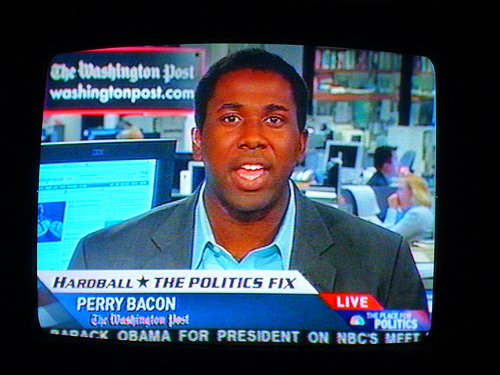<image>
Is there a announcer behind the woman? No. The announcer is not behind the woman. From this viewpoint, the announcer appears to be positioned elsewhere in the scene. 